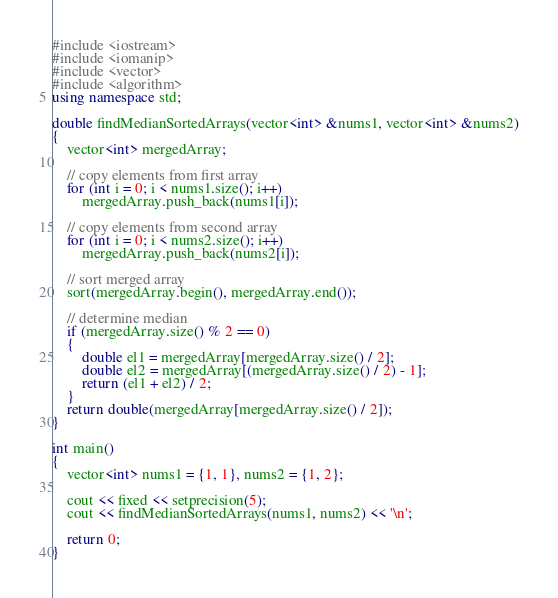<code> <loc_0><loc_0><loc_500><loc_500><_C++_>#include <iostream>
#include <iomanip>
#include <vector>
#include <algorithm>
using namespace std;

double findMedianSortedArrays(vector<int> &nums1, vector<int> &nums2)
{
    vector<int> mergedArray;

    // copy elements from first array
    for (int i = 0; i < nums1.size(); i++)
        mergedArray.push_back(nums1[i]);

    // copy elements from second array
    for (int i = 0; i < nums2.size(); i++)
        mergedArray.push_back(nums2[i]);

    // sort merged array
    sort(mergedArray.begin(), mergedArray.end());

    // determine median
    if (mergedArray.size() % 2 == 0)
    {
        double el1 = mergedArray[mergedArray.size() / 2];
        double el2 = mergedArray[(mergedArray.size() / 2) - 1];
        return (el1 + el2) / 2;
    }
    return double(mergedArray[mergedArray.size() / 2]);
}

int main()
{
    vector<int> nums1 = {1, 1}, nums2 = {1, 2};

    cout << fixed << setprecision(5);
    cout << findMedianSortedArrays(nums1, nums2) << '\n';

    return 0;
}</code> 